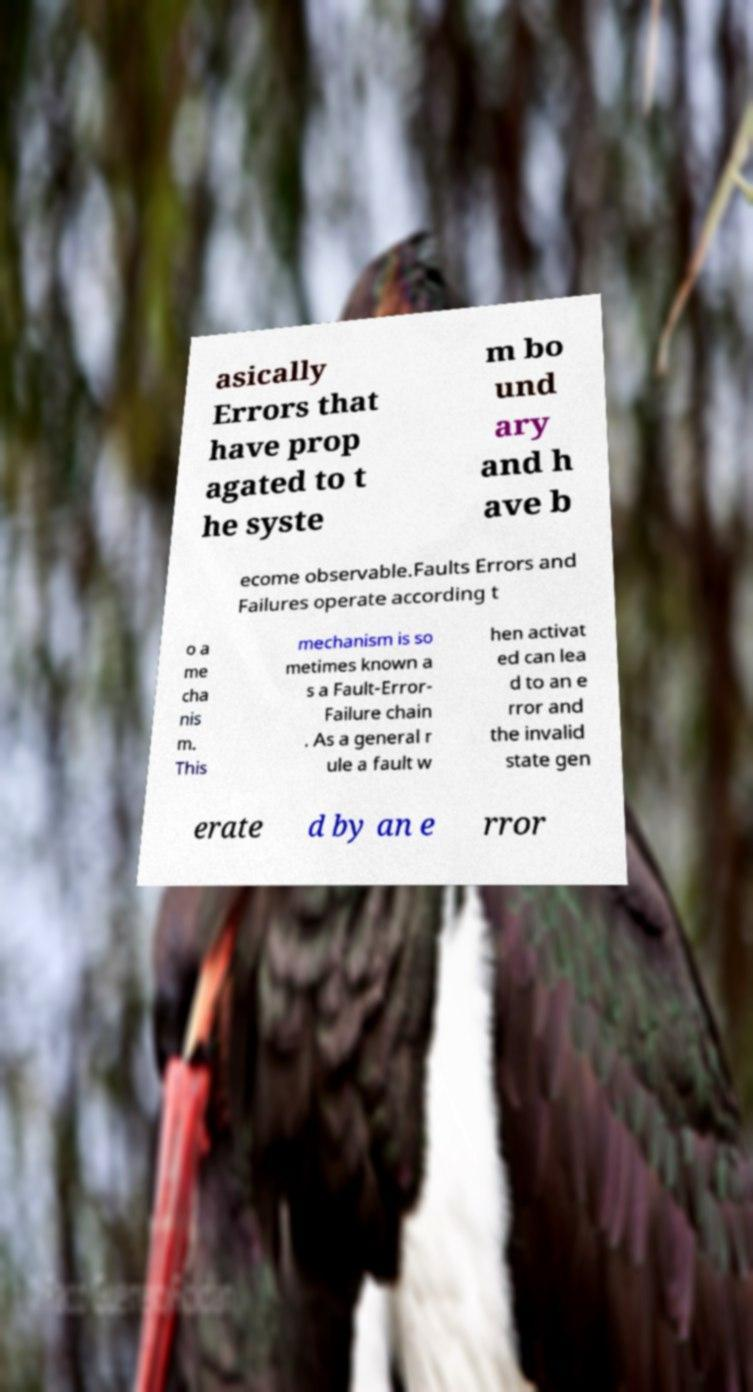Can you read and provide the text displayed in the image?This photo seems to have some interesting text. Can you extract and type it out for me? asically Errors that have prop agated to t he syste m bo und ary and h ave b ecome observable.Faults Errors and Failures operate according t o a me cha nis m. This mechanism is so metimes known a s a Fault-Error- Failure chain . As a general r ule a fault w hen activat ed can lea d to an e rror and the invalid state gen erate d by an e rror 